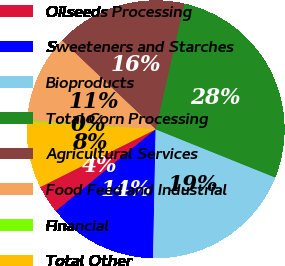<chart> <loc_0><loc_0><loc_500><loc_500><pie_chart><fcel>Oilseeds Processing<fcel>Sweeteners and Starches<fcel>Bioproducts<fcel>Total Corn Processing<fcel>Agricultural Services<fcel>Food Feed and Industrial<fcel>Financial<fcel>Total Other<nl><fcel>3.55%<fcel>13.75%<fcel>19.22%<fcel>27.54%<fcel>16.49%<fcel>11.01%<fcel>0.17%<fcel>8.27%<nl></chart> 